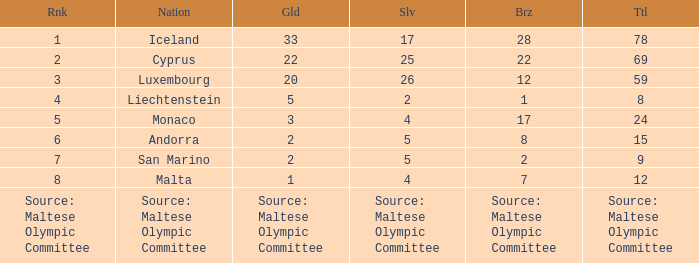What is the complete medal sum for the nation that holds 5 gold medals? 8.0. I'm looking to parse the entire table for insights. Could you assist me with that? {'header': ['Rnk', 'Nation', 'Gld', 'Slv', 'Brz', 'Ttl'], 'rows': [['1', 'Iceland', '33', '17', '28', '78'], ['2', 'Cyprus', '22', '25', '22', '69'], ['3', 'Luxembourg', '20', '26', '12', '59'], ['4', 'Liechtenstein', '5', '2', '1', '8'], ['5', 'Monaco', '3', '4', '17', '24'], ['6', 'Andorra', '2', '5', '8', '15'], ['7', 'San Marino', '2', '5', '2', '9'], ['8', 'Malta', '1', '4', '7', '12'], ['Source: Maltese Olympic Committee', 'Source: Maltese Olympic Committee', 'Source: Maltese Olympic Committee', 'Source: Maltese Olympic Committee', 'Source: Maltese Olympic Committee', 'Source: Maltese Olympic Committee']]} 